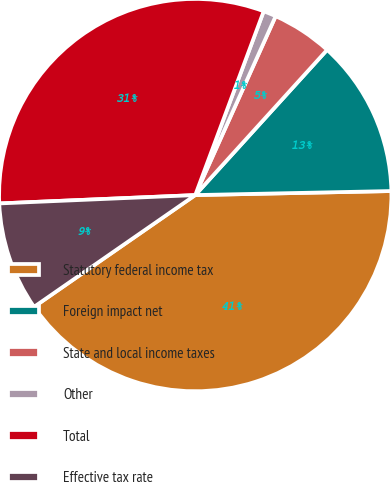Convert chart to OTSL. <chart><loc_0><loc_0><loc_500><loc_500><pie_chart><fcel>Statutory federal income tax<fcel>Foreign impact net<fcel>State and local income taxes<fcel>Other<fcel>Total<fcel>Effective tax rate<nl><fcel>40.68%<fcel>12.94%<fcel>5.01%<fcel>1.05%<fcel>31.35%<fcel>8.97%<nl></chart> 